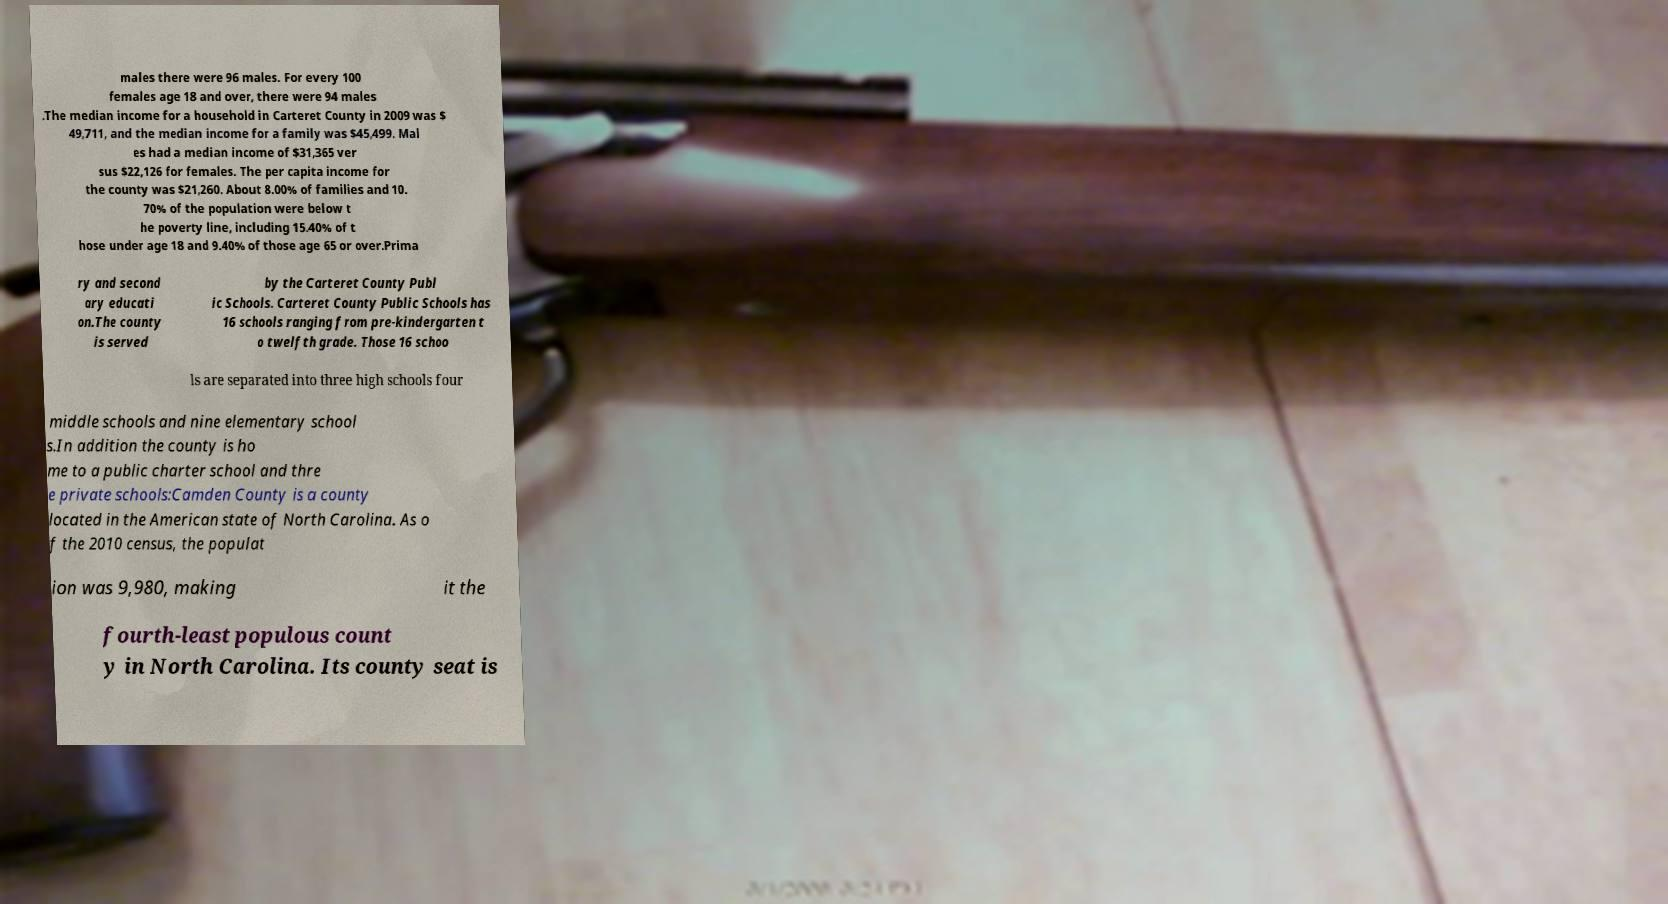Could you extract and type out the text from this image? males there were 96 males. For every 100 females age 18 and over, there were 94 males .The median income for a household in Carteret County in 2009 was $ 49,711, and the median income for a family was $45,499. Mal es had a median income of $31,365 ver sus $22,126 for females. The per capita income for the county was $21,260. About 8.00% of families and 10. 70% of the population were below t he poverty line, including 15.40% of t hose under age 18 and 9.40% of those age 65 or over.Prima ry and second ary educati on.The county is served by the Carteret County Publ ic Schools. Carteret County Public Schools has 16 schools ranging from pre-kindergarten t o twelfth grade. Those 16 schoo ls are separated into three high schools four middle schools and nine elementary school s.In addition the county is ho me to a public charter school and thre e private schools:Camden County is a county located in the American state of North Carolina. As o f the 2010 census, the populat ion was 9,980, making it the fourth-least populous count y in North Carolina. Its county seat is 